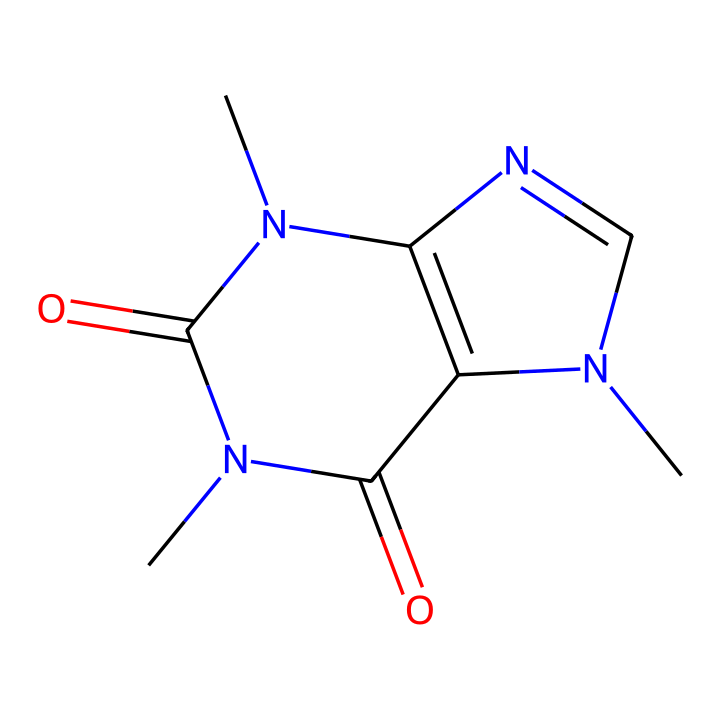What is the molecular formula of caffeine? The molecular formula can be determined by counting the atoms represented in the SMILES. Based on the structure, there are 8 carbon (C) atoms, 10 hydrogen (H) atoms, 4 nitrogen (N) atoms, and 2 oxygen (O) atoms. Thus, the combined formula is C8H10N4O2.
Answer: C8H10N4O2 How many nitrogen atoms are in the structure? By examining the SMILES representation, we can see the presence of four nitrogen atoms (indicated by 'N').
Answer: 4 What type of compound is caffeine? Caffeine is classified as an alkaloid due to the presence of nitrogen atoms in a cyclic structure. Alkaloids are nitrogen-containing compounds that often have significant pharmacological effects.
Answer: alkaloid What type of arrangement does caffeine have? The arrangement in the caffeine structure is described as a fused bicyclic structure, which consists of two interconnected rings, essential in many biologically active compounds.
Answer: fused bicyclic Explain the significance of the carbonyl groups in caffeine. The two carbonyl (C=O) groups are located in the structure and play a crucial role in the compound's reactivity and interactions with biological targets. Carbonyl functional groups are often involved in hydrogen bonding and contribute to the pharmacological activity of the compound.
Answer: reactivity and interactions How does the structure impact caffeine's solubility? The combination of polar and non-polar regions in the structure, particularly due to the presence of nitrogen and oxygen atoms, enhances caffeine's solubility in water and organic solvents, making it effectively bioavailable.
Answer: solubility in water What role do the nitrogen atoms play in caffeine's effects? The nitrogen atoms contribute to the formation of hydrogen bonds and the ability of caffeine to interact with adenosine receptors in the brain, which is key to its stimulant effects.
Answer: interaction with adenosine receptors 